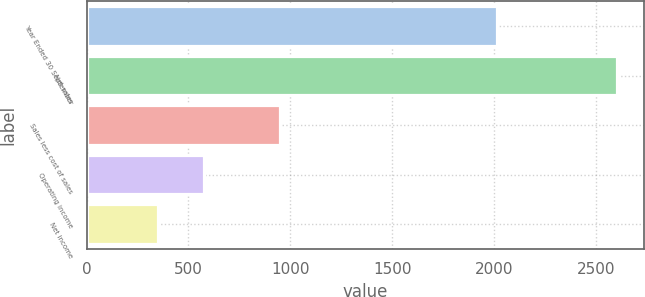<chart> <loc_0><loc_0><loc_500><loc_500><bar_chart><fcel>Year Ended 30 September<fcel>Net sales<fcel>Sales less cost of sales<fcel>Operating income<fcel>Net income<nl><fcel>2015<fcel>2604.3<fcel>949.2<fcel>576.33<fcel>351<nl></chart> 